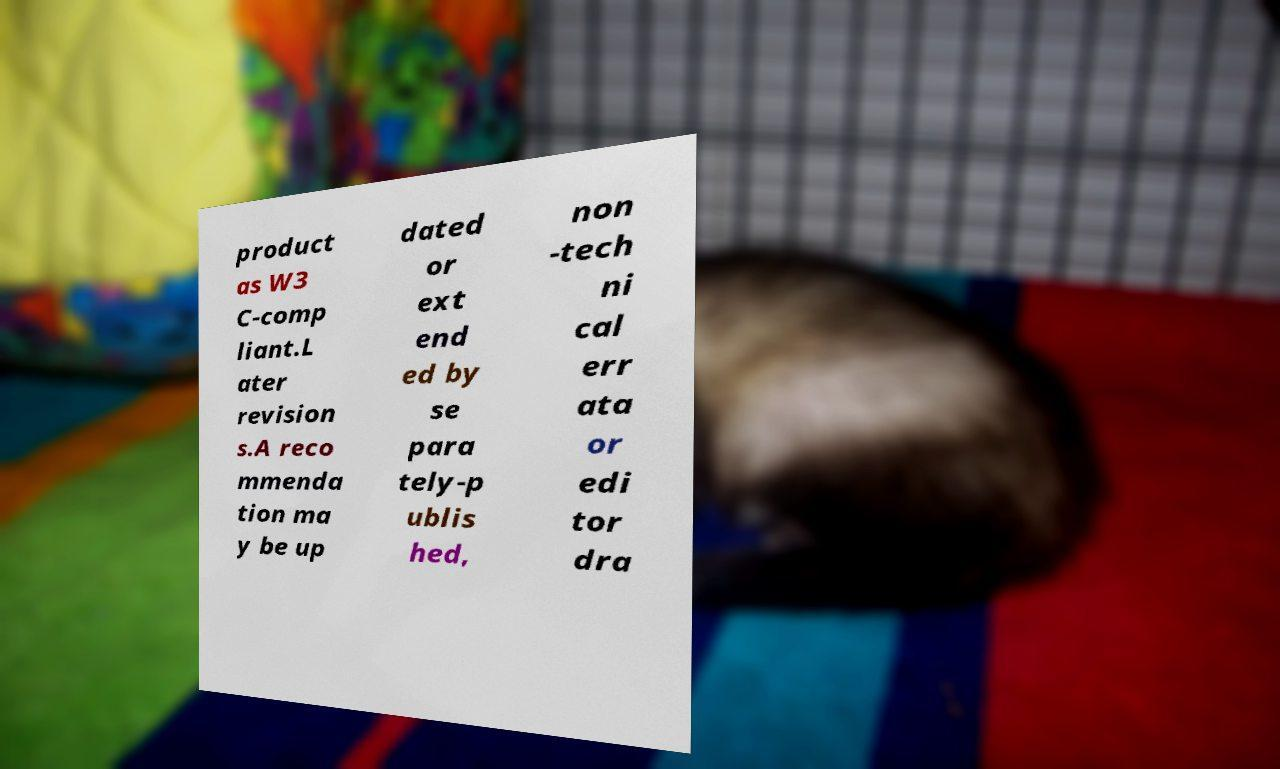For documentation purposes, I need the text within this image transcribed. Could you provide that? product as W3 C-comp liant.L ater revision s.A reco mmenda tion ma y be up dated or ext end ed by se para tely-p ublis hed, non -tech ni cal err ata or edi tor dra 